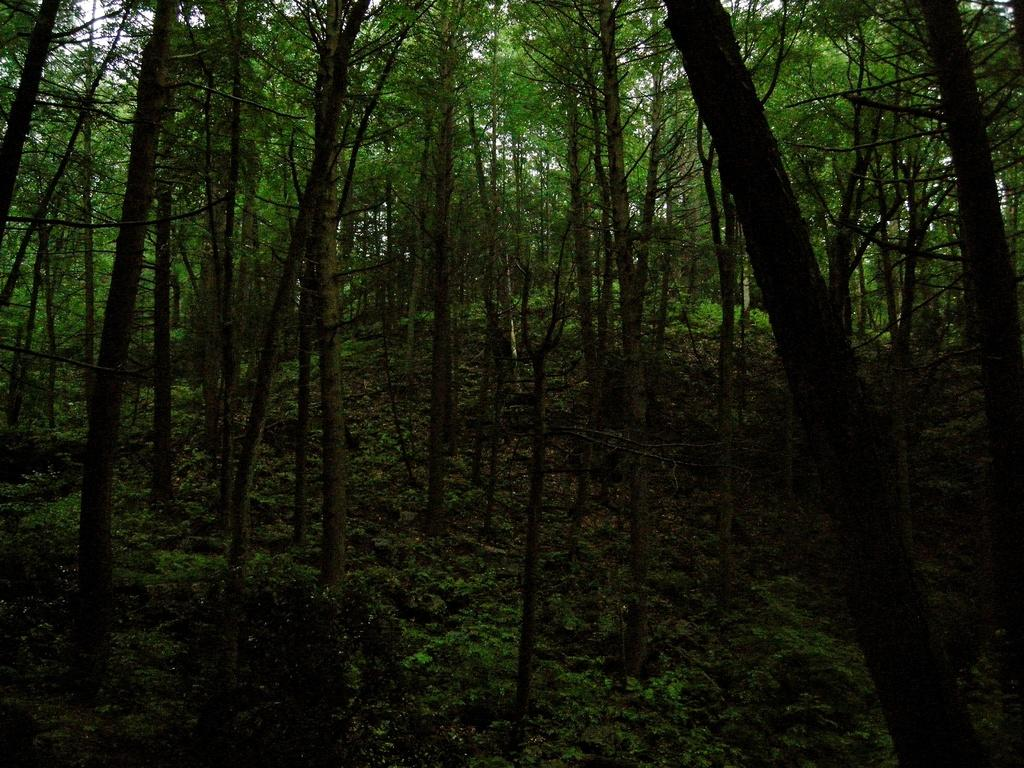What type of vegetation is in the foreground of the image? There are trees in the foreground of the image. What part of the natural environment is visible in the background of the image? The sky is visible in the background of the image. Reasoning: Let'g: Let's think step by step in order to produce the conversation. We start by identifying the main subjects and objects in the image based on the provided facts. We then formulate questions that focus on the location and characteristics of these subjects and objects, ensuring that each question can be answered definitively with the information given. We avoid yes/no questions and ensure that the language is simple and clear. Absurd Question/Answer: Where is the dad in the image? There is no dad present in the image. How many ducks can be seen swimming in the foreground of the image? There are no ducks present in the image; it features trees in the foreground. What type of jail can be seen in the image? There is no jail present in the image. 